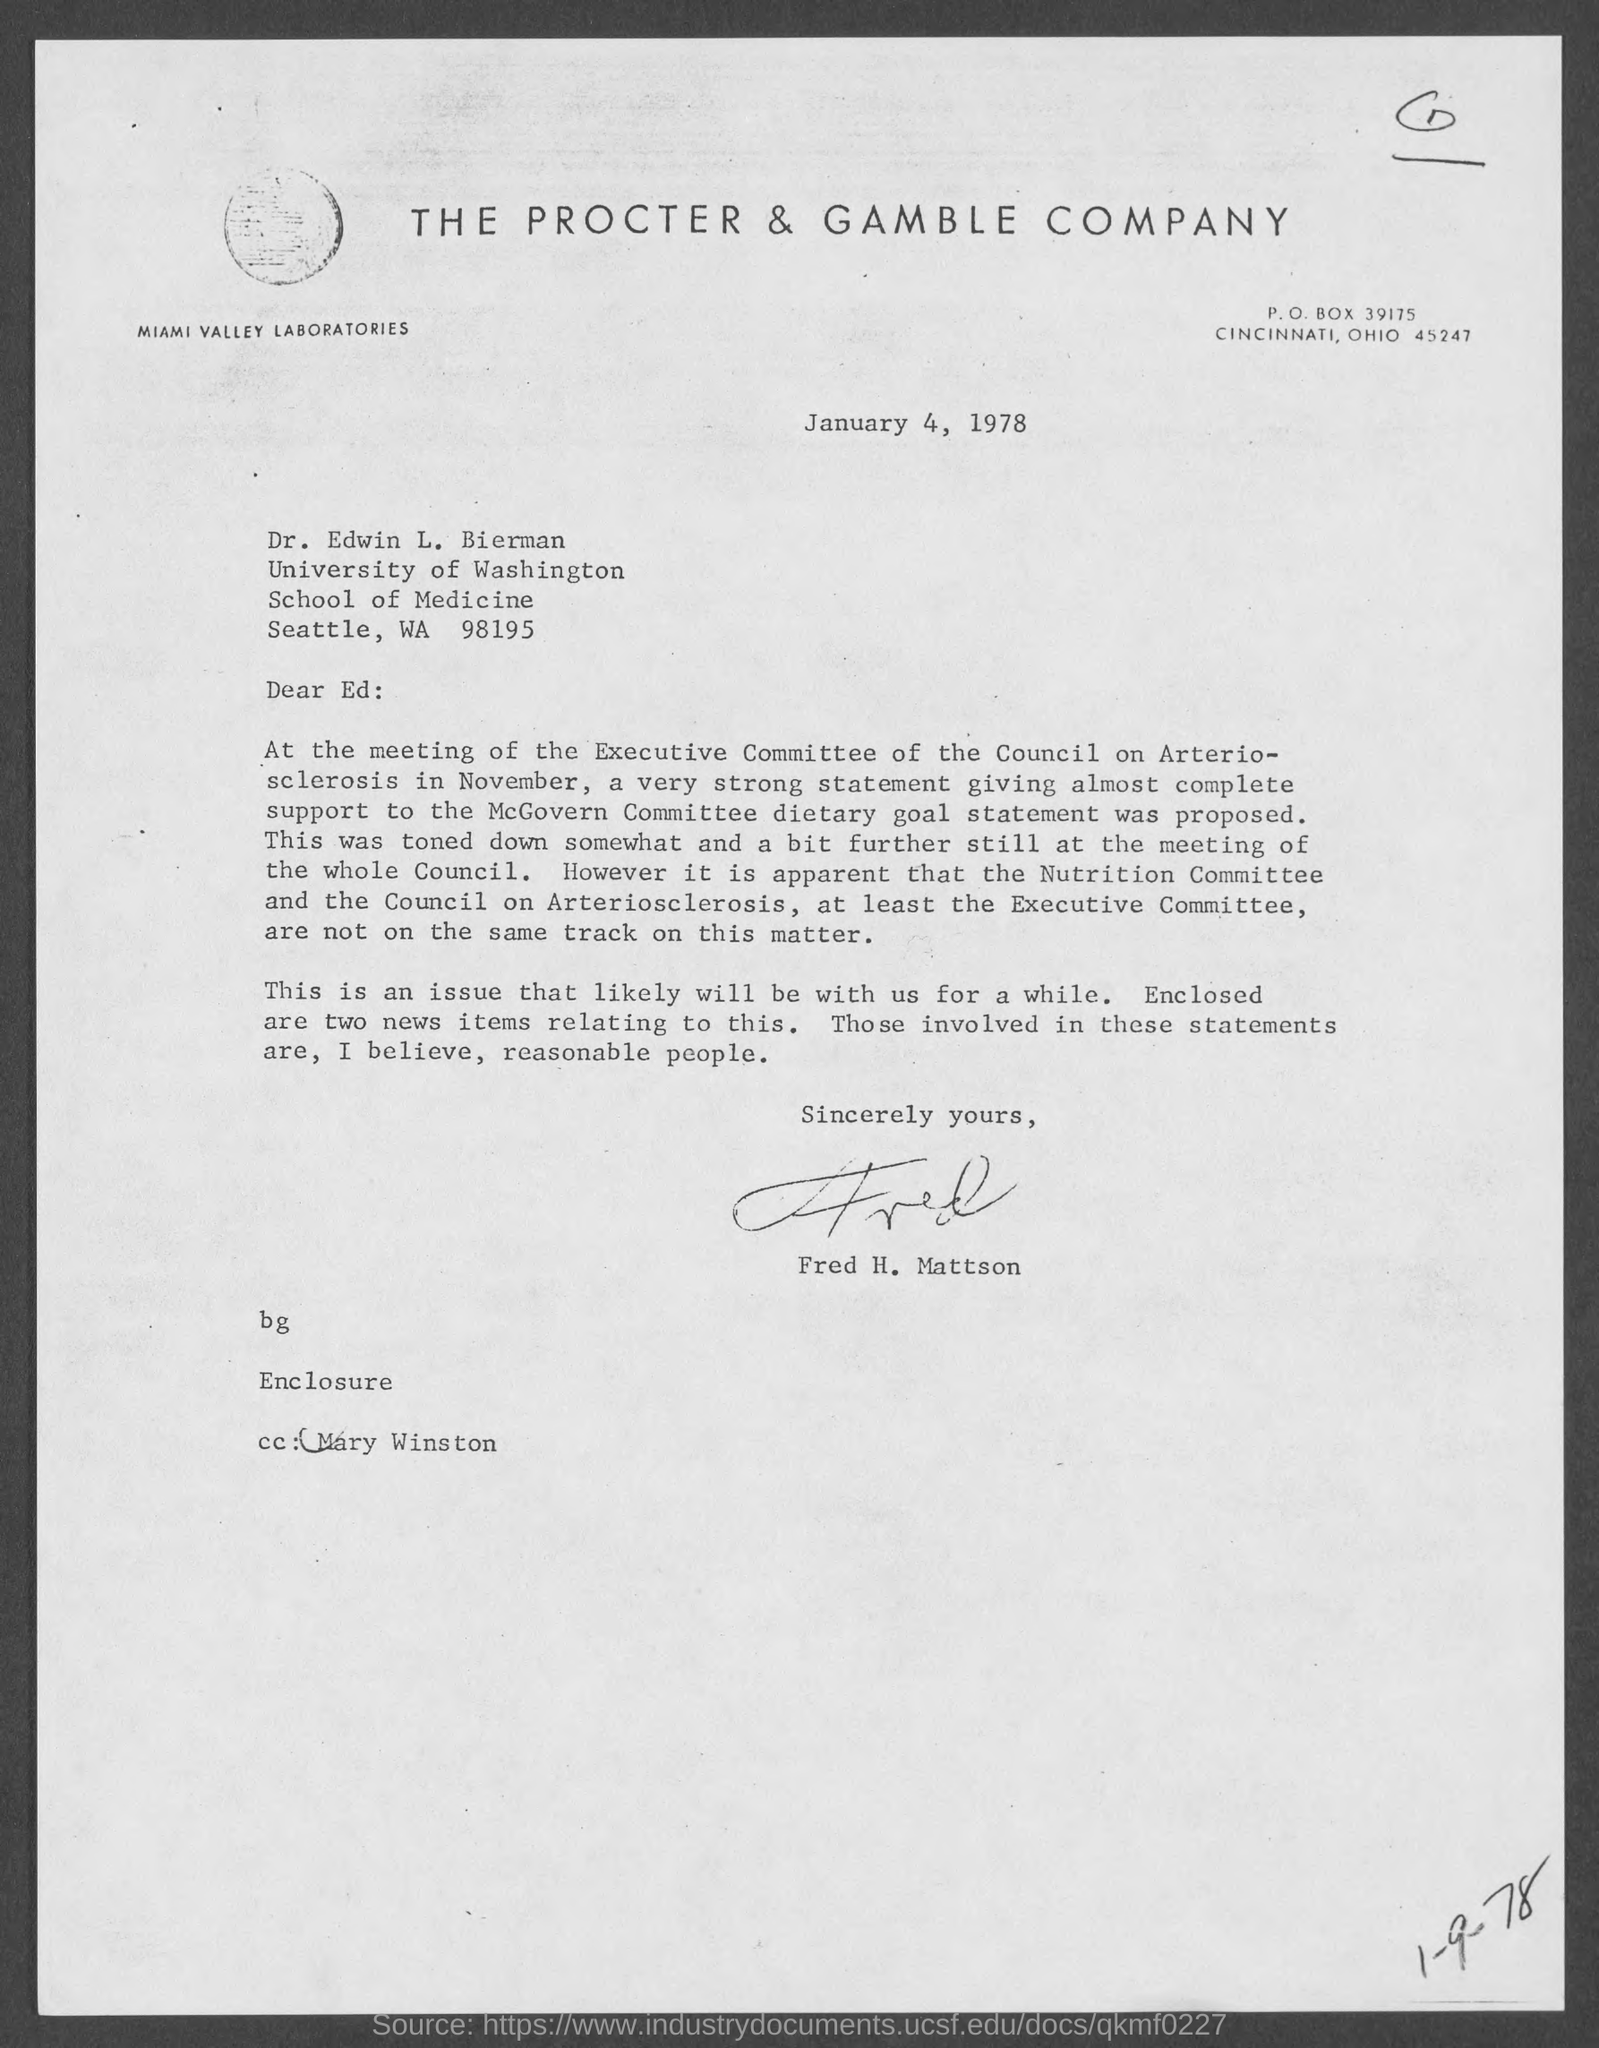Which company is mentioned in the letter head?
Offer a terse response. The Procter & Gamble Company. What is the issued date of this letter?
Offer a terse response. January 4, 1978. Who has signed this letter?
Your response must be concise. Fred H. Mattson. Who is mentioned in the CC of this letter?
Give a very brief answer. Mary Winston. 